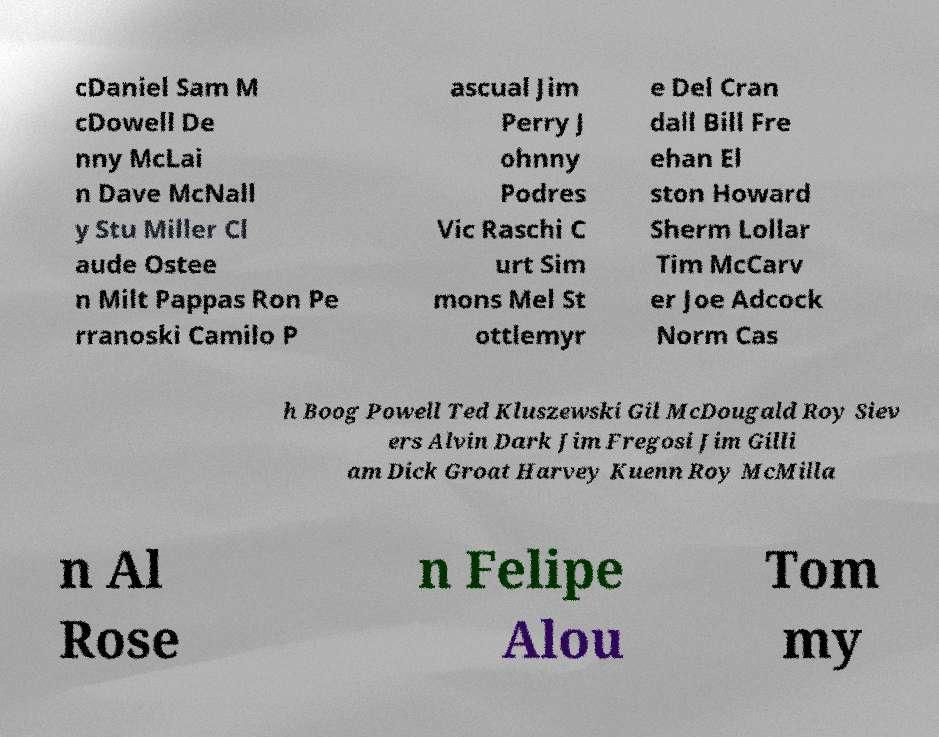For documentation purposes, I need the text within this image transcribed. Could you provide that? cDaniel Sam M cDowell De nny McLai n Dave McNall y Stu Miller Cl aude Ostee n Milt Pappas Ron Pe rranoski Camilo P ascual Jim Perry J ohnny Podres Vic Raschi C urt Sim mons Mel St ottlemyr e Del Cran dall Bill Fre ehan El ston Howard Sherm Lollar Tim McCarv er Joe Adcock Norm Cas h Boog Powell Ted Kluszewski Gil McDougald Roy Siev ers Alvin Dark Jim Fregosi Jim Gilli am Dick Groat Harvey Kuenn Roy McMilla n Al Rose n Felipe Alou Tom my 